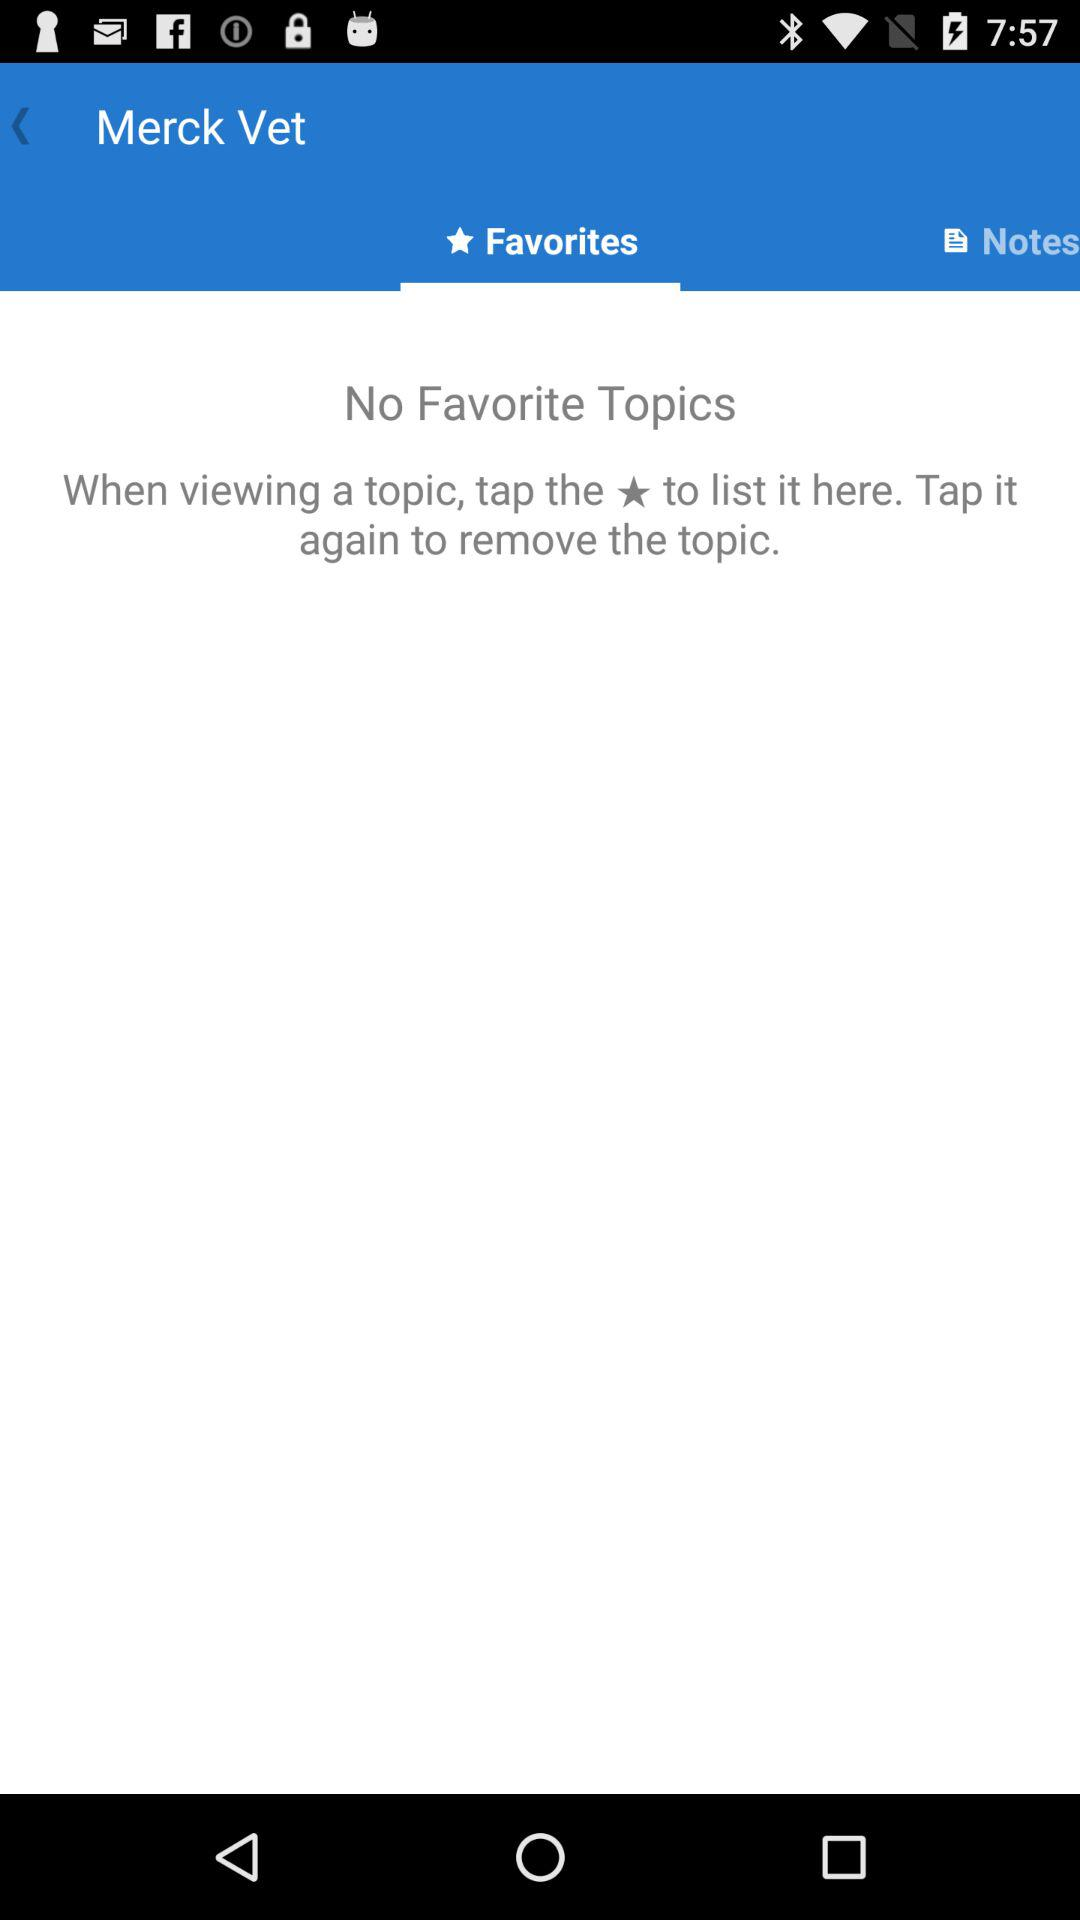Which tab is selected? The selected tab is "Favorites". 